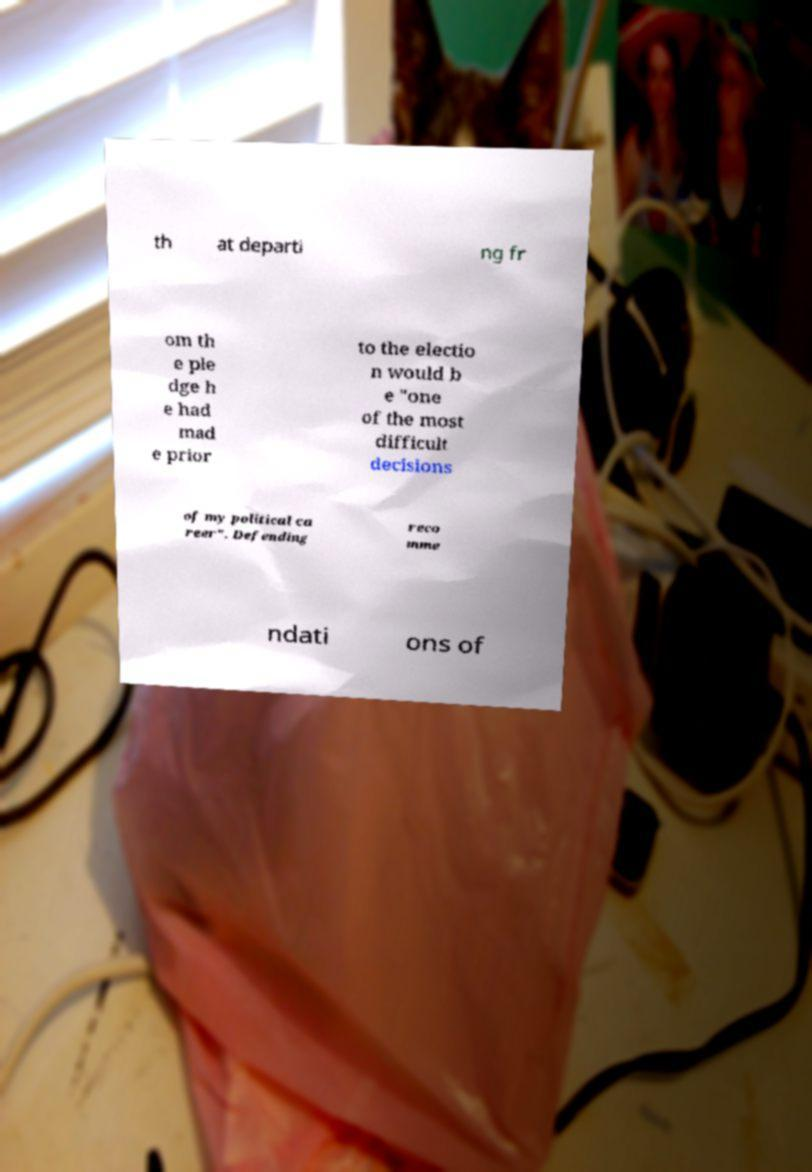There's text embedded in this image that I need extracted. Can you transcribe it verbatim? th at departi ng fr om th e ple dge h e had mad e prior to the electio n would b e "one of the most difficult decisions of my political ca reer". Defending reco mme ndati ons of 